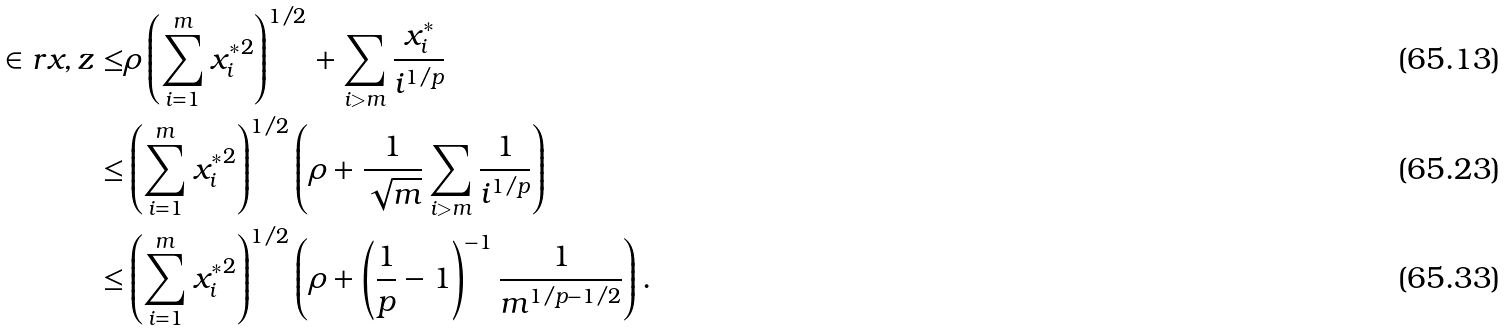Convert formula to latex. <formula><loc_0><loc_0><loc_500><loc_500>\in r { x , z } \leq & \rho \left ( \sum _ { i = 1 } ^ { m } { x _ { i } ^ { * } } ^ { 2 } \right ) ^ { 1 / 2 } + \sum _ { i > m } \frac { x _ { i } ^ { * } } { i ^ { 1 / p } } \\ \leq & \left ( \sum _ { i = 1 } ^ { m } { x _ { i } ^ { * } } ^ { 2 } \right ) ^ { 1 / 2 } \left ( \rho + \frac { 1 } { \sqrt { m } } \sum _ { i > m } \frac { 1 } { i ^ { 1 / p } } \right ) \\ \leq & \left ( \sum _ { i = 1 } ^ { m } { x _ { i } ^ { * } } ^ { 2 } \right ) ^ { 1 / 2 } \left ( \rho + \left ( \frac { 1 } { p } - 1 \right ) ^ { - 1 } \frac { 1 } { m ^ { 1 / p - 1 / 2 } } \right ) .</formula> 